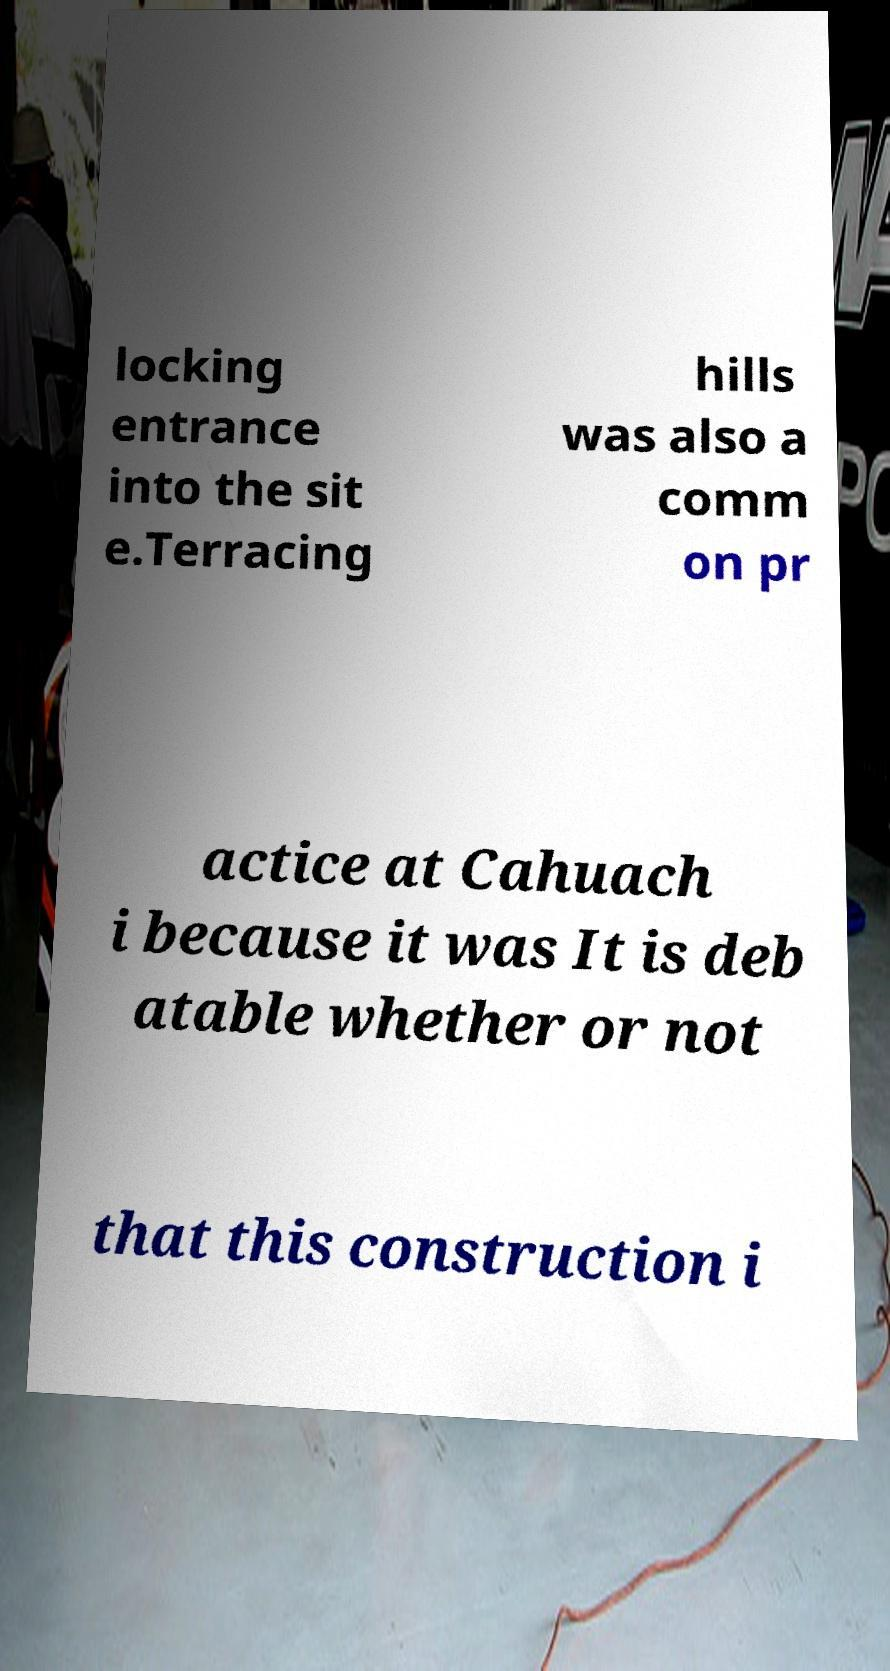I need the written content from this picture converted into text. Can you do that? locking entrance into the sit e.Terracing hills was also a comm on pr actice at Cahuach i because it was It is deb atable whether or not that this construction i 